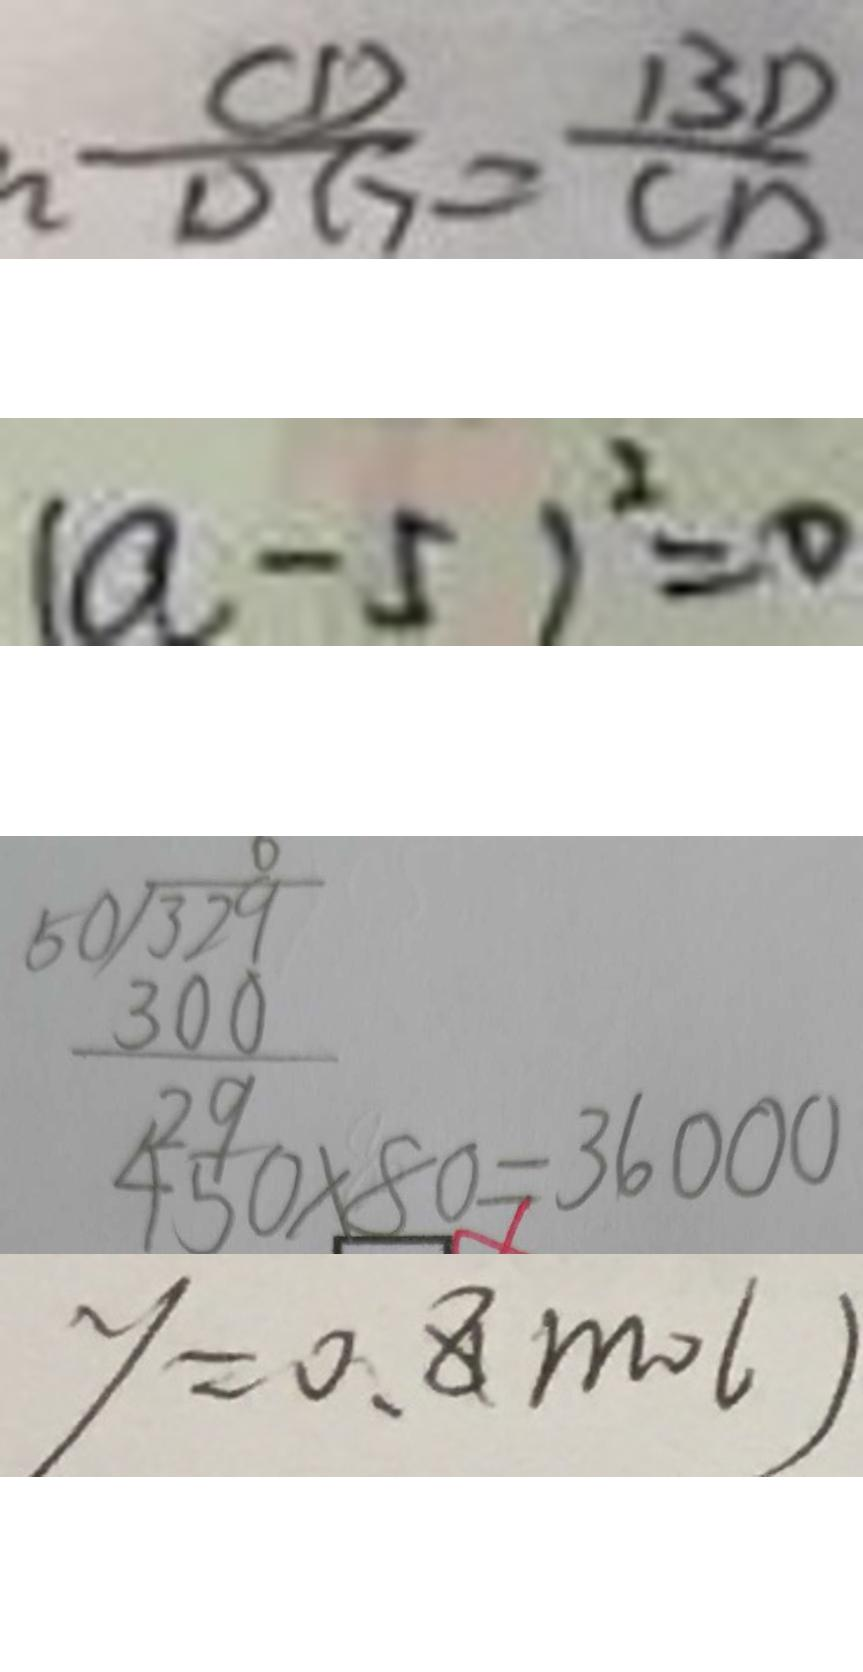Convert formula to latex. <formula><loc_0><loc_0><loc_500><loc_500>\frac { C D } { D G } = \frac { B D } { C D } 
 ( a - 5 ) ^ { 2 } = 0 
 4 5 0 \times 8 0 = 3 6 0 0 0 
 y = 0 . 8 ( m o l )</formula> 